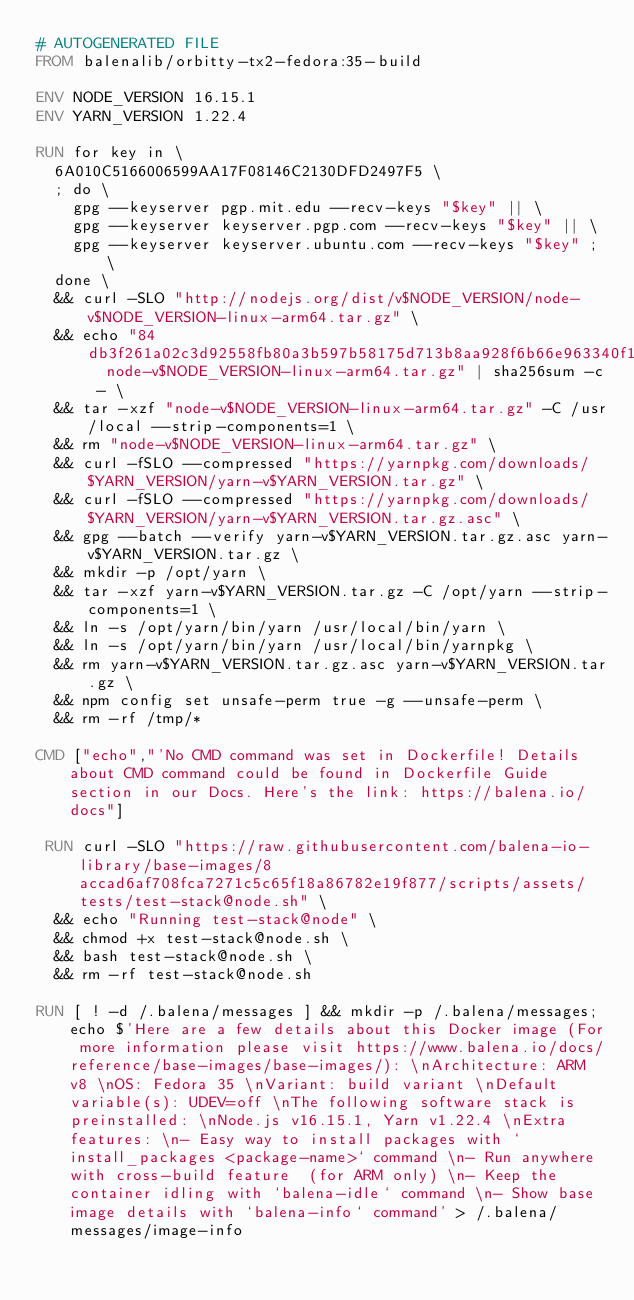<code> <loc_0><loc_0><loc_500><loc_500><_Dockerfile_># AUTOGENERATED FILE
FROM balenalib/orbitty-tx2-fedora:35-build

ENV NODE_VERSION 16.15.1
ENV YARN_VERSION 1.22.4

RUN for key in \
	6A010C5166006599AA17F08146C2130DFD2497F5 \
	; do \
		gpg --keyserver pgp.mit.edu --recv-keys "$key" || \
		gpg --keyserver keyserver.pgp.com --recv-keys "$key" || \
		gpg --keyserver keyserver.ubuntu.com --recv-keys "$key" ; \
	done \
	&& curl -SLO "http://nodejs.org/dist/v$NODE_VERSION/node-v$NODE_VERSION-linux-arm64.tar.gz" \
	&& echo "84db3f261a02c3d92558fb80a3b597b58175d713b8aa928f6b66e963340f1faf  node-v$NODE_VERSION-linux-arm64.tar.gz" | sha256sum -c - \
	&& tar -xzf "node-v$NODE_VERSION-linux-arm64.tar.gz" -C /usr/local --strip-components=1 \
	&& rm "node-v$NODE_VERSION-linux-arm64.tar.gz" \
	&& curl -fSLO --compressed "https://yarnpkg.com/downloads/$YARN_VERSION/yarn-v$YARN_VERSION.tar.gz" \
	&& curl -fSLO --compressed "https://yarnpkg.com/downloads/$YARN_VERSION/yarn-v$YARN_VERSION.tar.gz.asc" \
	&& gpg --batch --verify yarn-v$YARN_VERSION.tar.gz.asc yarn-v$YARN_VERSION.tar.gz \
	&& mkdir -p /opt/yarn \
	&& tar -xzf yarn-v$YARN_VERSION.tar.gz -C /opt/yarn --strip-components=1 \
	&& ln -s /opt/yarn/bin/yarn /usr/local/bin/yarn \
	&& ln -s /opt/yarn/bin/yarn /usr/local/bin/yarnpkg \
	&& rm yarn-v$YARN_VERSION.tar.gz.asc yarn-v$YARN_VERSION.tar.gz \
	&& npm config set unsafe-perm true -g --unsafe-perm \
	&& rm -rf /tmp/*

CMD ["echo","'No CMD command was set in Dockerfile! Details about CMD command could be found in Dockerfile Guide section in our Docs. Here's the link: https://balena.io/docs"]

 RUN curl -SLO "https://raw.githubusercontent.com/balena-io-library/base-images/8accad6af708fca7271c5c65f18a86782e19f877/scripts/assets/tests/test-stack@node.sh" \
  && echo "Running test-stack@node" \
  && chmod +x test-stack@node.sh \
  && bash test-stack@node.sh \
  && rm -rf test-stack@node.sh 

RUN [ ! -d /.balena/messages ] && mkdir -p /.balena/messages; echo $'Here are a few details about this Docker image (For more information please visit https://www.balena.io/docs/reference/base-images/base-images/): \nArchitecture: ARM v8 \nOS: Fedora 35 \nVariant: build variant \nDefault variable(s): UDEV=off \nThe following software stack is preinstalled: \nNode.js v16.15.1, Yarn v1.22.4 \nExtra features: \n- Easy way to install packages with `install_packages <package-name>` command \n- Run anywhere with cross-build feature  (for ARM only) \n- Keep the container idling with `balena-idle` command \n- Show base image details with `balena-info` command' > /.balena/messages/image-info</code> 